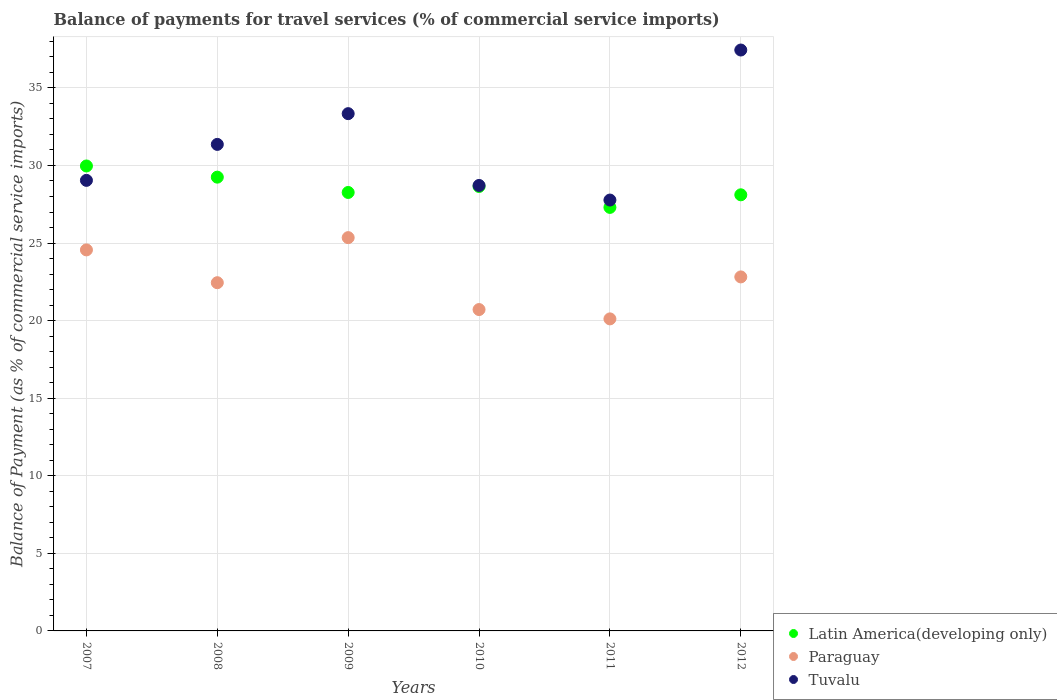How many different coloured dotlines are there?
Give a very brief answer. 3. What is the balance of payments for travel services in Tuvalu in 2008?
Provide a succinct answer. 31.36. Across all years, what is the maximum balance of payments for travel services in Paraguay?
Your answer should be very brief. 25.35. Across all years, what is the minimum balance of payments for travel services in Latin America(developing only)?
Offer a terse response. 27.3. What is the total balance of payments for travel services in Latin America(developing only) in the graph?
Your answer should be compact. 171.53. What is the difference between the balance of payments for travel services in Tuvalu in 2010 and that in 2012?
Provide a succinct answer. -8.73. What is the difference between the balance of payments for travel services in Latin America(developing only) in 2011 and the balance of payments for travel services in Paraguay in 2008?
Provide a succinct answer. 4.85. What is the average balance of payments for travel services in Paraguay per year?
Provide a succinct answer. 22.67. In the year 2009, what is the difference between the balance of payments for travel services in Tuvalu and balance of payments for travel services in Paraguay?
Ensure brevity in your answer.  7.99. What is the ratio of the balance of payments for travel services in Paraguay in 2010 to that in 2012?
Provide a succinct answer. 0.91. Is the difference between the balance of payments for travel services in Tuvalu in 2010 and 2011 greater than the difference between the balance of payments for travel services in Paraguay in 2010 and 2011?
Offer a very short reply. Yes. What is the difference between the highest and the second highest balance of payments for travel services in Latin America(developing only)?
Your answer should be very brief. 0.72. What is the difference between the highest and the lowest balance of payments for travel services in Tuvalu?
Keep it short and to the point. 9.67. In how many years, is the balance of payments for travel services in Latin America(developing only) greater than the average balance of payments for travel services in Latin America(developing only) taken over all years?
Your answer should be compact. 3. Is the sum of the balance of payments for travel services in Latin America(developing only) in 2008 and 2011 greater than the maximum balance of payments for travel services in Paraguay across all years?
Your response must be concise. Yes. Is the balance of payments for travel services in Paraguay strictly greater than the balance of payments for travel services in Latin America(developing only) over the years?
Your answer should be compact. No. How many dotlines are there?
Offer a very short reply. 3. How many years are there in the graph?
Keep it short and to the point. 6. Are the values on the major ticks of Y-axis written in scientific E-notation?
Offer a terse response. No. Does the graph contain any zero values?
Ensure brevity in your answer.  No. What is the title of the graph?
Offer a very short reply. Balance of payments for travel services (% of commercial service imports). Does "Bangladesh" appear as one of the legend labels in the graph?
Your answer should be very brief. No. What is the label or title of the X-axis?
Offer a terse response. Years. What is the label or title of the Y-axis?
Offer a very short reply. Balance of Payment (as % of commercial service imports). What is the Balance of Payment (as % of commercial service imports) of Latin America(developing only) in 2007?
Your answer should be very brief. 29.97. What is the Balance of Payment (as % of commercial service imports) of Paraguay in 2007?
Keep it short and to the point. 24.56. What is the Balance of Payment (as % of commercial service imports) of Tuvalu in 2007?
Make the answer very short. 29.04. What is the Balance of Payment (as % of commercial service imports) in Latin America(developing only) in 2008?
Your response must be concise. 29.25. What is the Balance of Payment (as % of commercial service imports) of Paraguay in 2008?
Keep it short and to the point. 22.44. What is the Balance of Payment (as % of commercial service imports) in Tuvalu in 2008?
Ensure brevity in your answer.  31.36. What is the Balance of Payment (as % of commercial service imports) of Latin America(developing only) in 2009?
Offer a very short reply. 28.26. What is the Balance of Payment (as % of commercial service imports) in Paraguay in 2009?
Ensure brevity in your answer.  25.35. What is the Balance of Payment (as % of commercial service imports) in Tuvalu in 2009?
Keep it short and to the point. 33.34. What is the Balance of Payment (as % of commercial service imports) in Latin America(developing only) in 2010?
Make the answer very short. 28.65. What is the Balance of Payment (as % of commercial service imports) in Paraguay in 2010?
Your response must be concise. 20.71. What is the Balance of Payment (as % of commercial service imports) of Tuvalu in 2010?
Your answer should be compact. 28.71. What is the Balance of Payment (as % of commercial service imports) in Latin America(developing only) in 2011?
Ensure brevity in your answer.  27.3. What is the Balance of Payment (as % of commercial service imports) of Paraguay in 2011?
Offer a very short reply. 20.11. What is the Balance of Payment (as % of commercial service imports) of Tuvalu in 2011?
Provide a succinct answer. 27.77. What is the Balance of Payment (as % of commercial service imports) of Latin America(developing only) in 2012?
Your answer should be very brief. 28.11. What is the Balance of Payment (as % of commercial service imports) in Paraguay in 2012?
Offer a terse response. 22.82. What is the Balance of Payment (as % of commercial service imports) of Tuvalu in 2012?
Your answer should be compact. 37.44. Across all years, what is the maximum Balance of Payment (as % of commercial service imports) of Latin America(developing only)?
Provide a short and direct response. 29.97. Across all years, what is the maximum Balance of Payment (as % of commercial service imports) of Paraguay?
Offer a terse response. 25.35. Across all years, what is the maximum Balance of Payment (as % of commercial service imports) of Tuvalu?
Your response must be concise. 37.44. Across all years, what is the minimum Balance of Payment (as % of commercial service imports) in Latin America(developing only)?
Provide a succinct answer. 27.3. Across all years, what is the minimum Balance of Payment (as % of commercial service imports) of Paraguay?
Give a very brief answer. 20.11. Across all years, what is the minimum Balance of Payment (as % of commercial service imports) of Tuvalu?
Your response must be concise. 27.77. What is the total Balance of Payment (as % of commercial service imports) of Latin America(developing only) in the graph?
Your answer should be very brief. 171.53. What is the total Balance of Payment (as % of commercial service imports) in Paraguay in the graph?
Give a very brief answer. 135.99. What is the total Balance of Payment (as % of commercial service imports) of Tuvalu in the graph?
Provide a short and direct response. 187.66. What is the difference between the Balance of Payment (as % of commercial service imports) of Latin America(developing only) in 2007 and that in 2008?
Your answer should be compact. 0.72. What is the difference between the Balance of Payment (as % of commercial service imports) of Paraguay in 2007 and that in 2008?
Provide a short and direct response. 2.11. What is the difference between the Balance of Payment (as % of commercial service imports) of Tuvalu in 2007 and that in 2008?
Keep it short and to the point. -2.32. What is the difference between the Balance of Payment (as % of commercial service imports) of Latin America(developing only) in 2007 and that in 2009?
Your answer should be very brief. 1.71. What is the difference between the Balance of Payment (as % of commercial service imports) in Paraguay in 2007 and that in 2009?
Your answer should be compact. -0.79. What is the difference between the Balance of Payment (as % of commercial service imports) in Tuvalu in 2007 and that in 2009?
Provide a short and direct response. -4.3. What is the difference between the Balance of Payment (as % of commercial service imports) in Latin America(developing only) in 2007 and that in 2010?
Your response must be concise. 1.32. What is the difference between the Balance of Payment (as % of commercial service imports) in Paraguay in 2007 and that in 2010?
Ensure brevity in your answer.  3.85. What is the difference between the Balance of Payment (as % of commercial service imports) of Tuvalu in 2007 and that in 2010?
Offer a terse response. 0.33. What is the difference between the Balance of Payment (as % of commercial service imports) in Latin America(developing only) in 2007 and that in 2011?
Give a very brief answer. 2.67. What is the difference between the Balance of Payment (as % of commercial service imports) in Paraguay in 2007 and that in 2011?
Make the answer very short. 4.45. What is the difference between the Balance of Payment (as % of commercial service imports) in Tuvalu in 2007 and that in 2011?
Make the answer very short. 1.27. What is the difference between the Balance of Payment (as % of commercial service imports) in Latin America(developing only) in 2007 and that in 2012?
Make the answer very short. 1.86. What is the difference between the Balance of Payment (as % of commercial service imports) in Paraguay in 2007 and that in 2012?
Offer a very short reply. 1.74. What is the difference between the Balance of Payment (as % of commercial service imports) in Tuvalu in 2007 and that in 2012?
Offer a very short reply. -8.4. What is the difference between the Balance of Payment (as % of commercial service imports) in Paraguay in 2008 and that in 2009?
Provide a short and direct response. -2.9. What is the difference between the Balance of Payment (as % of commercial service imports) in Tuvalu in 2008 and that in 2009?
Provide a succinct answer. -1.98. What is the difference between the Balance of Payment (as % of commercial service imports) of Latin America(developing only) in 2008 and that in 2010?
Your answer should be compact. 0.6. What is the difference between the Balance of Payment (as % of commercial service imports) of Paraguay in 2008 and that in 2010?
Ensure brevity in your answer.  1.73. What is the difference between the Balance of Payment (as % of commercial service imports) of Tuvalu in 2008 and that in 2010?
Your answer should be compact. 2.65. What is the difference between the Balance of Payment (as % of commercial service imports) of Latin America(developing only) in 2008 and that in 2011?
Your response must be concise. 1.95. What is the difference between the Balance of Payment (as % of commercial service imports) of Paraguay in 2008 and that in 2011?
Your answer should be very brief. 2.33. What is the difference between the Balance of Payment (as % of commercial service imports) of Tuvalu in 2008 and that in 2011?
Give a very brief answer. 3.59. What is the difference between the Balance of Payment (as % of commercial service imports) of Latin America(developing only) in 2008 and that in 2012?
Ensure brevity in your answer.  1.14. What is the difference between the Balance of Payment (as % of commercial service imports) of Paraguay in 2008 and that in 2012?
Give a very brief answer. -0.37. What is the difference between the Balance of Payment (as % of commercial service imports) of Tuvalu in 2008 and that in 2012?
Provide a succinct answer. -6.08. What is the difference between the Balance of Payment (as % of commercial service imports) of Latin America(developing only) in 2009 and that in 2010?
Your response must be concise. -0.39. What is the difference between the Balance of Payment (as % of commercial service imports) in Paraguay in 2009 and that in 2010?
Your answer should be compact. 4.64. What is the difference between the Balance of Payment (as % of commercial service imports) of Tuvalu in 2009 and that in 2010?
Provide a short and direct response. 4.63. What is the difference between the Balance of Payment (as % of commercial service imports) of Latin America(developing only) in 2009 and that in 2011?
Provide a succinct answer. 0.96. What is the difference between the Balance of Payment (as % of commercial service imports) of Paraguay in 2009 and that in 2011?
Provide a succinct answer. 5.24. What is the difference between the Balance of Payment (as % of commercial service imports) of Tuvalu in 2009 and that in 2011?
Provide a short and direct response. 5.57. What is the difference between the Balance of Payment (as % of commercial service imports) of Latin America(developing only) in 2009 and that in 2012?
Make the answer very short. 0.15. What is the difference between the Balance of Payment (as % of commercial service imports) of Paraguay in 2009 and that in 2012?
Keep it short and to the point. 2.53. What is the difference between the Balance of Payment (as % of commercial service imports) of Tuvalu in 2009 and that in 2012?
Ensure brevity in your answer.  -4.1. What is the difference between the Balance of Payment (as % of commercial service imports) in Latin America(developing only) in 2010 and that in 2011?
Provide a short and direct response. 1.35. What is the difference between the Balance of Payment (as % of commercial service imports) in Paraguay in 2010 and that in 2011?
Your answer should be very brief. 0.6. What is the difference between the Balance of Payment (as % of commercial service imports) of Tuvalu in 2010 and that in 2011?
Your answer should be compact. 0.94. What is the difference between the Balance of Payment (as % of commercial service imports) of Latin America(developing only) in 2010 and that in 2012?
Offer a very short reply. 0.54. What is the difference between the Balance of Payment (as % of commercial service imports) of Paraguay in 2010 and that in 2012?
Offer a very short reply. -2.1. What is the difference between the Balance of Payment (as % of commercial service imports) of Tuvalu in 2010 and that in 2012?
Give a very brief answer. -8.73. What is the difference between the Balance of Payment (as % of commercial service imports) of Latin America(developing only) in 2011 and that in 2012?
Offer a terse response. -0.81. What is the difference between the Balance of Payment (as % of commercial service imports) in Paraguay in 2011 and that in 2012?
Give a very brief answer. -2.71. What is the difference between the Balance of Payment (as % of commercial service imports) in Tuvalu in 2011 and that in 2012?
Your answer should be very brief. -9.67. What is the difference between the Balance of Payment (as % of commercial service imports) of Latin America(developing only) in 2007 and the Balance of Payment (as % of commercial service imports) of Paraguay in 2008?
Make the answer very short. 7.52. What is the difference between the Balance of Payment (as % of commercial service imports) of Latin America(developing only) in 2007 and the Balance of Payment (as % of commercial service imports) of Tuvalu in 2008?
Ensure brevity in your answer.  -1.39. What is the difference between the Balance of Payment (as % of commercial service imports) in Paraguay in 2007 and the Balance of Payment (as % of commercial service imports) in Tuvalu in 2008?
Provide a succinct answer. -6.8. What is the difference between the Balance of Payment (as % of commercial service imports) in Latin America(developing only) in 2007 and the Balance of Payment (as % of commercial service imports) in Paraguay in 2009?
Offer a very short reply. 4.62. What is the difference between the Balance of Payment (as % of commercial service imports) in Latin America(developing only) in 2007 and the Balance of Payment (as % of commercial service imports) in Tuvalu in 2009?
Your answer should be compact. -3.37. What is the difference between the Balance of Payment (as % of commercial service imports) in Paraguay in 2007 and the Balance of Payment (as % of commercial service imports) in Tuvalu in 2009?
Provide a short and direct response. -8.78. What is the difference between the Balance of Payment (as % of commercial service imports) of Latin America(developing only) in 2007 and the Balance of Payment (as % of commercial service imports) of Paraguay in 2010?
Offer a terse response. 9.25. What is the difference between the Balance of Payment (as % of commercial service imports) in Latin America(developing only) in 2007 and the Balance of Payment (as % of commercial service imports) in Tuvalu in 2010?
Offer a terse response. 1.26. What is the difference between the Balance of Payment (as % of commercial service imports) of Paraguay in 2007 and the Balance of Payment (as % of commercial service imports) of Tuvalu in 2010?
Give a very brief answer. -4.15. What is the difference between the Balance of Payment (as % of commercial service imports) of Latin America(developing only) in 2007 and the Balance of Payment (as % of commercial service imports) of Paraguay in 2011?
Make the answer very short. 9.86. What is the difference between the Balance of Payment (as % of commercial service imports) in Latin America(developing only) in 2007 and the Balance of Payment (as % of commercial service imports) in Tuvalu in 2011?
Make the answer very short. 2.2. What is the difference between the Balance of Payment (as % of commercial service imports) in Paraguay in 2007 and the Balance of Payment (as % of commercial service imports) in Tuvalu in 2011?
Offer a very short reply. -3.21. What is the difference between the Balance of Payment (as % of commercial service imports) in Latin America(developing only) in 2007 and the Balance of Payment (as % of commercial service imports) in Paraguay in 2012?
Ensure brevity in your answer.  7.15. What is the difference between the Balance of Payment (as % of commercial service imports) in Latin America(developing only) in 2007 and the Balance of Payment (as % of commercial service imports) in Tuvalu in 2012?
Make the answer very short. -7.47. What is the difference between the Balance of Payment (as % of commercial service imports) of Paraguay in 2007 and the Balance of Payment (as % of commercial service imports) of Tuvalu in 2012?
Provide a succinct answer. -12.88. What is the difference between the Balance of Payment (as % of commercial service imports) in Latin America(developing only) in 2008 and the Balance of Payment (as % of commercial service imports) in Paraguay in 2009?
Your response must be concise. 3.9. What is the difference between the Balance of Payment (as % of commercial service imports) of Latin America(developing only) in 2008 and the Balance of Payment (as % of commercial service imports) of Tuvalu in 2009?
Provide a succinct answer. -4.09. What is the difference between the Balance of Payment (as % of commercial service imports) of Paraguay in 2008 and the Balance of Payment (as % of commercial service imports) of Tuvalu in 2009?
Make the answer very short. -10.9. What is the difference between the Balance of Payment (as % of commercial service imports) in Latin America(developing only) in 2008 and the Balance of Payment (as % of commercial service imports) in Paraguay in 2010?
Give a very brief answer. 8.53. What is the difference between the Balance of Payment (as % of commercial service imports) of Latin America(developing only) in 2008 and the Balance of Payment (as % of commercial service imports) of Tuvalu in 2010?
Provide a short and direct response. 0.54. What is the difference between the Balance of Payment (as % of commercial service imports) in Paraguay in 2008 and the Balance of Payment (as % of commercial service imports) in Tuvalu in 2010?
Provide a succinct answer. -6.27. What is the difference between the Balance of Payment (as % of commercial service imports) of Latin America(developing only) in 2008 and the Balance of Payment (as % of commercial service imports) of Paraguay in 2011?
Give a very brief answer. 9.14. What is the difference between the Balance of Payment (as % of commercial service imports) in Latin America(developing only) in 2008 and the Balance of Payment (as % of commercial service imports) in Tuvalu in 2011?
Keep it short and to the point. 1.48. What is the difference between the Balance of Payment (as % of commercial service imports) of Paraguay in 2008 and the Balance of Payment (as % of commercial service imports) of Tuvalu in 2011?
Ensure brevity in your answer.  -5.33. What is the difference between the Balance of Payment (as % of commercial service imports) in Latin America(developing only) in 2008 and the Balance of Payment (as % of commercial service imports) in Paraguay in 2012?
Provide a succinct answer. 6.43. What is the difference between the Balance of Payment (as % of commercial service imports) in Latin America(developing only) in 2008 and the Balance of Payment (as % of commercial service imports) in Tuvalu in 2012?
Give a very brief answer. -8.19. What is the difference between the Balance of Payment (as % of commercial service imports) of Paraguay in 2008 and the Balance of Payment (as % of commercial service imports) of Tuvalu in 2012?
Your answer should be very brief. -15. What is the difference between the Balance of Payment (as % of commercial service imports) of Latin America(developing only) in 2009 and the Balance of Payment (as % of commercial service imports) of Paraguay in 2010?
Ensure brevity in your answer.  7.55. What is the difference between the Balance of Payment (as % of commercial service imports) of Latin America(developing only) in 2009 and the Balance of Payment (as % of commercial service imports) of Tuvalu in 2010?
Your answer should be compact. -0.45. What is the difference between the Balance of Payment (as % of commercial service imports) of Paraguay in 2009 and the Balance of Payment (as % of commercial service imports) of Tuvalu in 2010?
Ensure brevity in your answer.  -3.36. What is the difference between the Balance of Payment (as % of commercial service imports) of Latin America(developing only) in 2009 and the Balance of Payment (as % of commercial service imports) of Paraguay in 2011?
Keep it short and to the point. 8.15. What is the difference between the Balance of Payment (as % of commercial service imports) in Latin America(developing only) in 2009 and the Balance of Payment (as % of commercial service imports) in Tuvalu in 2011?
Your answer should be compact. 0.49. What is the difference between the Balance of Payment (as % of commercial service imports) in Paraguay in 2009 and the Balance of Payment (as % of commercial service imports) in Tuvalu in 2011?
Offer a very short reply. -2.42. What is the difference between the Balance of Payment (as % of commercial service imports) of Latin America(developing only) in 2009 and the Balance of Payment (as % of commercial service imports) of Paraguay in 2012?
Provide a short and direct response. 5.44. What is the difference between the Balance of Payment (as % of commercial service imports) in Latin America(developing only) in 2009 and the Balance of Payment (as % of commercial service imports) in Tuvalu in 2012?
Provide a short and direct response. -9.18. What is the difference between the Balance of Payment (as % of commercial service imports) of Paraguay in 2009 and the Balance of Payment (as % of commercial service imports) of Tuvalu in 2012?
Offer a very short reply. -12.09. What is the difference between the Balance of Payment (as % of commercial service imports) in Latin America(developing only) in 2010 and the Balance of Payment (as % of commercial service imports) in Paraguay in 2011?
Provide a short and direct response. 8.53. What is the difference between the Balance of Payment (as % of commercial service imports) of Latin America(developing only) in 2010 and the Balance of Payment (as % of commercial service imports) of Tuvalu in 2011?
Provide a short and direct response. 0.87. What is the difference between the Balance of Payment (as % of commercial service imports) in Paraguay in 2010 and the Balance of Payment (as % of commercial service imports) in Tuvalu in 2011?
Make the answer very short. -7.06. What is the difference between the Balance of Payment (as % of commercial service imports) in Latin America(developing only) in 2010 and the Balance of Payment (as % of commercial service imports) in Paraguay in 2012?
Offer a very short reply. 5.83. What is the difference between the Balance of Payment (as % of commercial service imports) of Latin America(developing only) in 2010 and the Balance of Payment (as % of commercial service imports) of Tuvalu in 2012?
Offer a very short reply. -8.8. What is the difference between the Balance of Payment (as % of commercial service imports) in Paraguay in 2010 and the Balance of Payment (as % of commercial service imports) in Tuvalu in 2012?
Give a very brief answer. -16.73. What is the difference between the Balance of Payment (as % of commercial service imports) in Latin America(developing only) in 2011 and the Balance of Payment (as % of commercial service imports) in Paraguay in 2012?
Make the answer very short. 4.48. What is the difference between the Balance of Payment (as % of commercial service imports) in Latin America(developing only) in 2011 and the Balance of Payment (as % of commercial service imports) in Tuvalu in 2012?
Your response must be concise. -10.14. What is the difference between the Balance of Payment (as % of commercial service imports) of Paraguay in 2011 and the Balance of Payment (as % of commercial service imports) of Tuvalu in 2012?
Offer a very short reply. -17.33. What is the average Balance of Payment (as % of commercial service imports) in Latin America(developing only) per year?
Make the answer very short. 28.59. What is the average Balance of Payment (as % of commercial service imports) of Paraguay per year?
Give a very brief answer. 22.67. What is the average Balance of Payment (as % of commercial service imports) in Tuvalu per year?
Offer a very short reply. 31.28. In the year 2007, what is the difference between the Balance of Payment (as % of commercial service imports) in Latin America(developing only) and Balance of Payment (as % of commercial service imports) in Paraguay?
Ensure brevity in your answer.  5.41. In the year 2007, what is the difference between the Balance of Payment (as % of commercial service imports) of Latin America(developing only) and Balance of Payment (as % of commercial service imports) of Tuvalu?
Your answer should be very brief. 0.93. In the year 2007, what is the difference between the Balance of Payment (as % of commercial service imports) of Paraguay and Balance of Payment (as % of commercial service imports) of Tuvalu?
Keep it short and to the point. -4.48. In the year 2008, what is the difference between the Balance of Payment (as % of commercial service imports) in Latin America(developing only) and Balance of Payment (as % of commercial service imports) in Paraguay?
Your response must be concise. 6.8. In the year 2008, what is the difference between the Balance of Payment (as % of commercial service imports) in Latin America(developing only) and Balance of Payment (as % of commercial service imports) in Tuvalu?
Give a very brief answer. -2.11. In the year 2008, what is the difference between the Balance of Payment (as % of commercial service imports) in Paraguay and Balance of Payment (as % of commercial service imports) in Tuvalu?
Provide a succinct answer. -8.91. In the year 2009, what is the difference between the Balance of Payment (as % of commercial service imports) in Latin America(developing only) and Balance of Payment (as % of commercial service imports) in Paraguay?
Give a very brief answer. 2.91. In the year 2009, what is the difference between the Balance of Payment (as % of commercial service imports) in Latin America(developing only) and Balance of Payment (as % of commercial service imports) in Tuvalu?
Keep it short and to the point. -5.08. In the year 2009, what is the difference between the Balance of Payment (as % of commercial service imports) in Paraguay and Balance of Payment (as % of commercial service imports) in Tuvalu?
Offer a very short reply. -7.99. In the year 2010, what is the difference between the Balance of Payment (as % of commercial service imports) in Latin America(developing only) and Balance of Payment (as % of commercial service imports) in Paraguay?
Offer a terse response. 7.93. In the year 2010, what is the difference between the Balance of Payment (as % of commercial service imports) in Latin America(developing only) and Balance of Payment (as % of commercial service imports) in Tuvalu?
Your response must be concise. -0.07. In the year 2010, what is the difference between the Balance of Payment (as % of commercial service imports) in Paraguay and Balance of Payment (as % of commercial service imports) in Tuvalu?
Offer a very short reply. -8. In the year 2011, what is the difference between the Balance of Payment (as % of commercial service imports) of Latin America(developing only) and Balance of Payment (as % of commercial service imports) of Paraguay?
Make the answer very short. 7.19. In the year 2011, what is the difference between the Balance of Payment (as % of commercial service imports) in Latin America(developing only) and Balance of Payment (as % of commercial service imports) in Tuvalu?
Provide a short and direct response. -0.47. In the year 2011, what is the difference between the Balance of Payment (as % of commercial service imports) of Paraguay and Balance of Payment (as % of commercial service imports) of Tuvalu?
Keep it short and to the point. -7.66. In the year 2012, what is the difference between the Balance of Payment (as % of commercial service imports) of Latin America(developing only) and Balance of Payment (as % of commercial service imports) of Paraguay?
Keep it short and to the point. 5.29. In the year 2012, what is the difference between the Balance of Payment (as % of commercial service imports) of Latin America(developing only) and Balance of Payment (as % of commercial service imports) of Tuvalu?
Give a very brief answer. -9.33. In the year 2012, what is the difference between the Balance of Payment (as % of commercial service imports) of Paraguay and Balance of Payment (as % of commercial service imports) of Tuvalu?
Provide a short and direct response. -14.62. What is the ratio of the Balance of Payment (as % of commercial service imports) in Latin America(developing only) in 2007 to that in 2008?
Keep it short and to the point. 1.02. What is the ratio of the Balance of Payment (as % of commercial service imports) of Paraguay in 2007 to that in 2008?
Your answer should be very brief. 1.09. What is the ratio of the Balance of Payment (as % of commercial service imports) in Tuvalu in 2007 to that in 2008?
Offer a terse response. 0.93. What is the ratio of the Balance of Payment (as % of commercial service imports) in Latin America(developing only) in 2007 to that in 2009?
Provide a succinct answer. 1.06. What is the ratio of the Balance of Payment (as % of commercial service imports) in Paraguay in 2007 to that in 2009?
Make the answer very short. 0.97. What is the ratio of the Balance of Payment (as % of commercial service imports) in Tuvalu in 2007 to that in 2009?
Your response must be concise. 0.87. What is the ratio of the Balance of Payment (as % of commercial service imports) of Latin America(developing only) in 2007 to that in 2010?
Your response must be concise. 1.05. What is the ratio of the Balance of Payment (as % of commercial service imports) in Paraguay in 2007 to that in 2010?
Offer a very short reply. 1.19. What is the ratio of the Balance of Payment (as % of commercial service imports) in Tuvalu in 2007 to that in 2010?
Keep it short and to the point. 1.01. What is the ratio of the Balance of Payment (as % of commercial service imports) of Latin America(developing only) in 2007 to that in 2011?
Offer a terse response. 1.1. What is the ratio of the Balance of Payment (as % of commercial service imports) in Paraguay in 2007 to that in 2011?
Offer a terse response. 1.22. What is the ratio of the Balance of Payment (as % of commercial service imports) of Tuvalu in 2007 to that in 2011?
Keep it short and to the point. 1.05. What is the ratio of the Balance of Payment (as % of commercial service imports) of Latin America(developing only) in 2007 to that in 2012?
Your response must be concise. 1.07. What is the ratio of the Balance of Payment (as % of commercial service imports) of Paraguay in 2007 to that in 2012?
Give a very brief answer. 1.08. What is the ratio of the Balance of Payment (as % of commercial service imports) in Tuvalu in 2007 to that in 2012?
Ensure brevity in your answer.  0.78. What is the ratio of the Balance of Payment (as % of commercial service imports) in Latin America(developing only) in 2008 to that in 2009?
Provide a short and direct response. 1.03. What is the ratio of the Balance of Payment (as % of commercial service imports) of Paraguay in 2008 to that in 2009?
Offer a very short reply. 0.89. What is the ratio of the Balance of Payment (as % of commercial service imports) in Tuvalu in 2008 to that in 2009?
Your answer should be compact. 0.94. What is the ratio of the Balance of Payment (as % of commercial service imports) of Paraguay in 2008 to that in 2010?
Make the answer very short. 1.08. What is the ratio of the Balance of Payment (as % of commercial service imports) in Tuvalu in 2008 to that in 2010?
Your response must be concise. 1.09. What is the ratio of the Balance of Payment (as % of commercial service imports) of Latin America(developing only) in 2008 to that in 2011?
Offer a very short reply. 1.07. What is the ratio of the Balance of Payment (as % of commercial service imports) in Paraguay in 2008 to that in 2011?
Your answer should be compact. 1.12. What is the ratio of the Balance of Payment (as % of commercial service imports) of Tuvalu in 2008 to that in 2011?
Your response must be concise. 1.13. What is the ratio of the Balance of Payment (as % of commercial service imports) of Latin America(developing only) in 2008 to that in 2012?
Make the answer very short. 1.04. What is the ratio of the Balance of Payment (as % of commercial service imports) of Paraguay in 2008 to that in 2012?
Your response must be concise. 0.98. What is the ratio of the Balance of Payment (as % of commercial service imports) of Tuvalu in 2008 to that in 2012?
Offer a very short reply. 0.84. What is the ratio of the Balance of Payment (as % of commercial service imports) of Latin America(developing only) in 2009 to that in 2010?
Provide a succinct answer. 0.99. What is the ratio of the Balance of Payment (as % of commercial service imports) in Paraguay in 2009 to that in 2010?
Provide a short and direct response. 1.22. What is the ratio of the Balance of Payment (as % of commercial service imports) in Tuvalu in 2009 to that in 2010?
Make the answer very short. 1.16. What is the ratio of the Balance of Payment (as % of commercial service imports) of Latin America(developing only) in 2009 to that in 2011?
Your response must be concise. 1.04. What is the ratio of the Balance of Payment (as % of commercial service imports) in Paraguay in 2009 to that in 2011?
Your response must be concise. 1.26. What is the ratio of the Balance of Payment (as % of commercial service imports) of Tuvalu in 2009 to that in 2011?
Provide a succinct answer. 1.2. What is the ratio of the Balance of Payment (as % of commercial service imports) in Latin America(developing only) in 2009 to that in 2012?
Offer a terse response. 1.01. What is the ratio of the Balance of Payment (as % of commercial service imports) of Paraguay in 2009 to that in 2012?
Provide a succinct answer. 1.11. What is the ratio of the Balance of Payment (as % of commercial service imports) of Tuvalu in 2009 to that in 2012?
Keep it short and to the point. 0.89. What is the ratio of the Balance of Payment (as % of commercial service imports) in Latin America(developing only) in 2010 to that in 2011?
Make the answer very short. 1.05. What is the ratio of the Balance of Payment (as % of commercial service imports) of Paraguay in 2010 to that in 2011?
Offer a very short reply. 1.03. What is the ratio of the Balance of Payment (as % of commercial service imports) in Tuvalu in 2010 to that in 2011?
Your answer should be very brief. 1.03. What is the ratio of the Balance of Payment (as % of commercial service imports) in Latin America(developing only) in 2010 to that in 2012?
Offer a terse response. 1.02. What is the ratio of the Balance of Payment (as % of commercial service imports) in Paraguay in 2010 to that in 2012?
Your answer should be very brief. 0.91. What is the ratio of the Balance of Payment (as % of commercial service imports) in Tuvalu in 2010 to that in 2012?
Ensure brevity in your answer.  0.77. What is the ratio of the Balance of Payment (as % of commercial service imports) of Latin America(developing only) in 2011 to that in 2012?
Your answer should be very brief. 0.97. What is the ratio of the Balance of Payment (as % of commercial service imports) in Paraguay in 2011 to that in 2012?
Your answer should be compact. 0.88. What is the ratio of the Balance of Payment (as % of commercial service imports) in Tuvalu in 2011 to that in 2012?
Give a very brief answer. 0.74. What is the difference between the highest and the second highest Balance of Payment (as % of commercial service imports) in Latin America(developing only)?
Provide a short and direct response. 0.72. What is the difference between the highest and the second highest Balance of Payment (as % of commercial service imports) in Paraguay?
Keep it short and to the point. 0.79. What is the difference between the highest and the second highest Balance of Payment (as % of commercial service imports) of Tuvalu?
Offer a terse response. 4.1. What is the difference between the highest and the lowest Balance of Payment (as % of commercial service imports) in Latin America(developing only)?
Provide a succinct answer. 2.67. What is the difference between the highest and the lowest Balance of Payment (as % of commercial service imports) in Paraguay?
Offer a terse response. 5.24. What is the difference between the highest and the lowest Balance of Payment (as % of commercial service imports) of Tuvalu?
Keep it short and to the point. 9.67. 